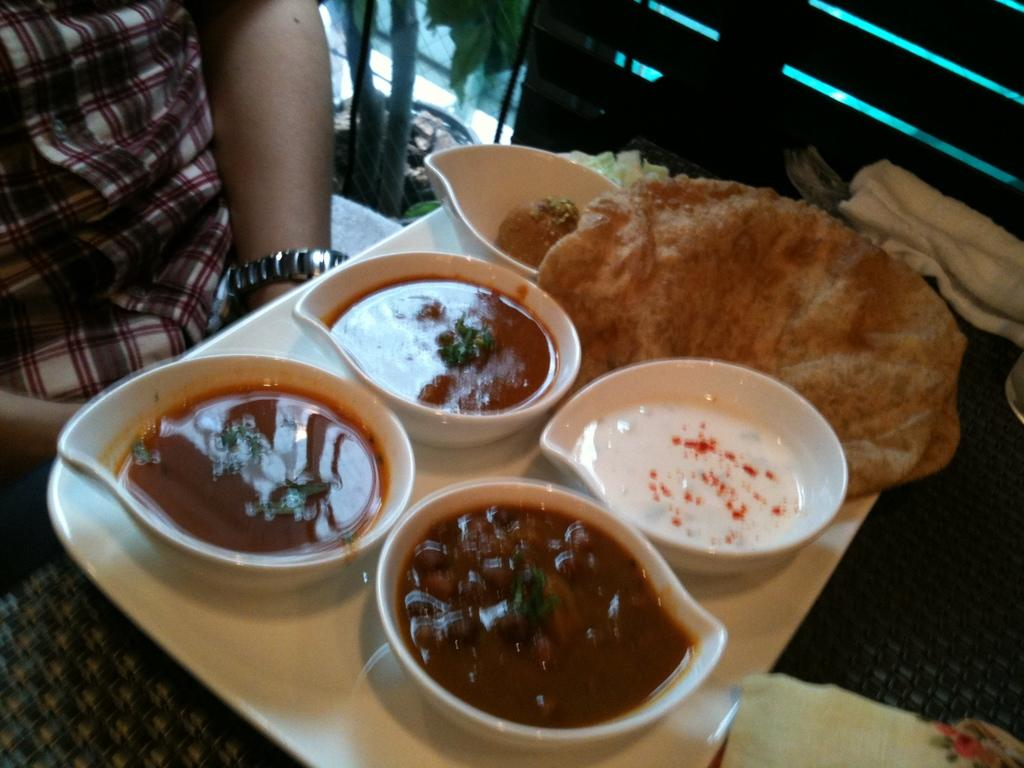What is on the plate that is visible in the image? There is food placed on a plate in the image. Where is the person located in the image? The person is sitting at the left side of the image. What can be seen through the glass door in the image? A planet is visible through the glass door in the image. How does the person plan to expand the carriage in the image? There is no carriage present in the image, so the question is not applicable. 